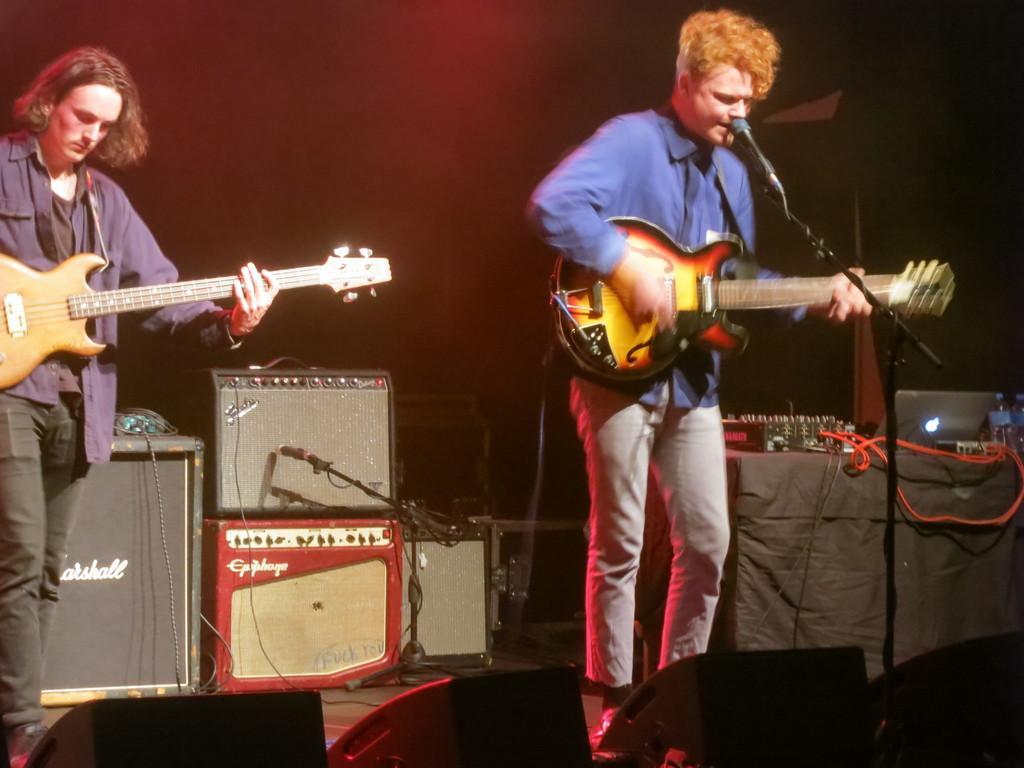Describe this image in one or two sentences. Tn the picture there are two musicians standing. The man to the right corner is singing and playing guitar as well. The man to the left corner is playing guitar. On the floor there are microphones, boxes and a table. On the table there is a audio mixer, a laptop, cable and bottle. 